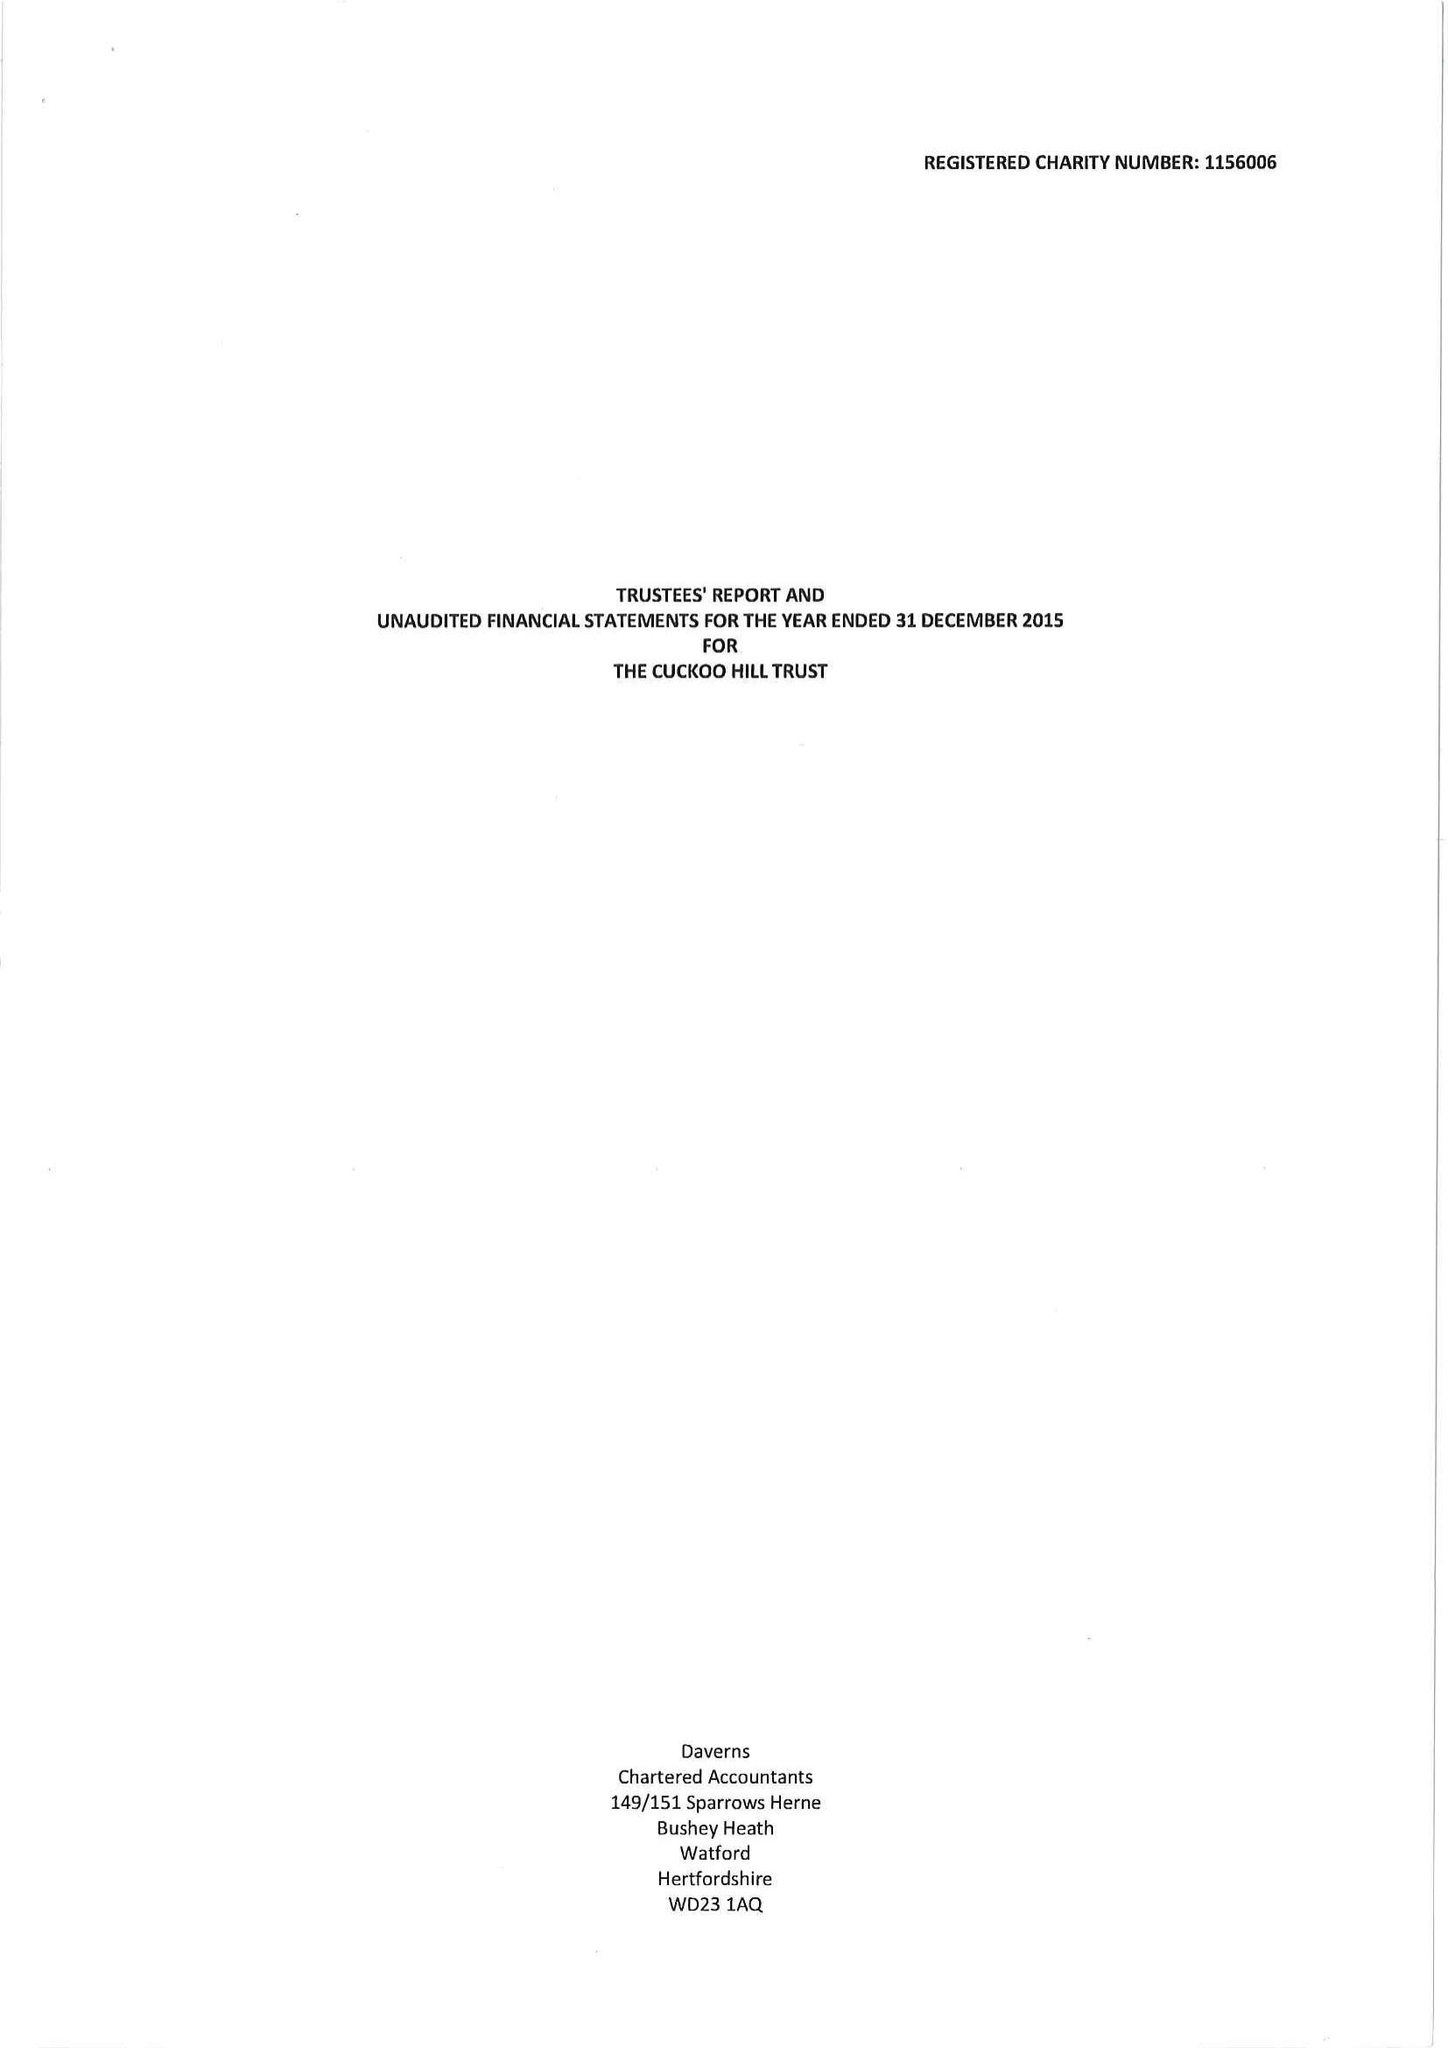What is the value for the spending_annually_in_british_pounds?
Answer the question using a single word or phrase. 131735.00 